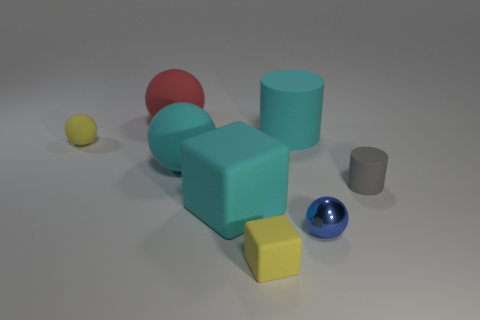Is there a rubber object that has the same color as the large rubber block?
Provide a short and direct response. Yes. What number of large blocks are the same color as the large rubber cylinder?
Your answer should be compact. 1. Is the color of the big matte cylinder the same as the big rubber sphere in front of the big cyan cylinder?
Your answer should be very brief. Yes. How many things are green matte things or small yellow rubber objects that are on the right side of the yellow rubber ball?
Provide a succinct answer. 1. There is a yellow matte object that is to the right of the small yellow rubber object that is behind the small metallic sphere; what is its size?
Your response must be concise. Small. Are there the same number of gray rubber cylinders behind the metallic sphere and big red spheres right of the tiny block?
Provide a succinct answer. No. There is a tiny gray rubber cylinder on the right side of the small blue thing; is there a object that is to the left of it?
Keep it short and to the point. Yes. There is a gray object that is the same material as the cyan sphere; what shape is it?
Provide a short and direct response. Cylinder. Are there any other things that are the same color as the big block?
Ensure brevity in your answer.  Yes. There is a small yellow thing that is on the left side of the cube on the right side of the big matte cube; what is it made of?
Your response must be concise. Rubber. 